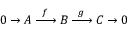<formula> <loc_0><loc_0><loc_500><loc_500>0 \to A \, { \xrightarrow { \ f \ } } \, B \, { \xrightarrow { \ g \ } } \, C \to 0</formula> 